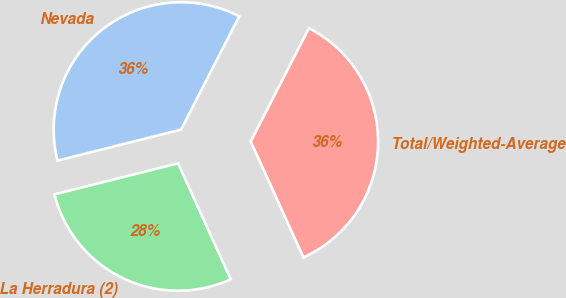Convert chart. <chart><loc_0><loc_0><loc_500><loc_500><pie_chart><fcel>Nevada<fcel>La Herradura (2)<fcel>Total/Weighted-Average<nl><fcel>36.47%<fcel>27.88%<fcel>35.66%<nl></chart> 